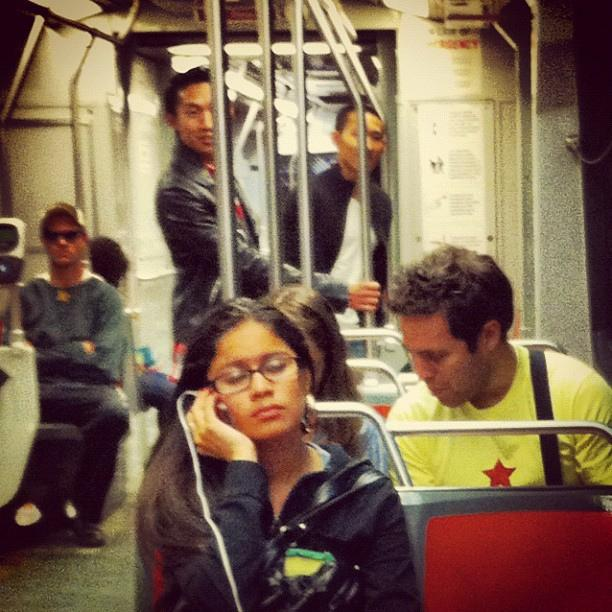The shape the man has on his yellow shirt is found on what flag?

Choices:
A) china
B) argentina
C) greece
D) sweden china 